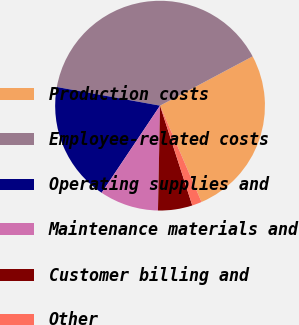<chart> <loc_0><loc_0><loc_500><loc_500><pie_chart><fcel>Production costs<fcel>Employee-related costs<fcel>Operating supplies and<fcel>Maintenance materials and<fcel>Customer billing and<fcel>Other<nl><fcel>26.31%<fcel>39.37%<fcel>18.45%<fcel>9.08%<fcel>5.29%<fcel>1.5%<nl></chart> 